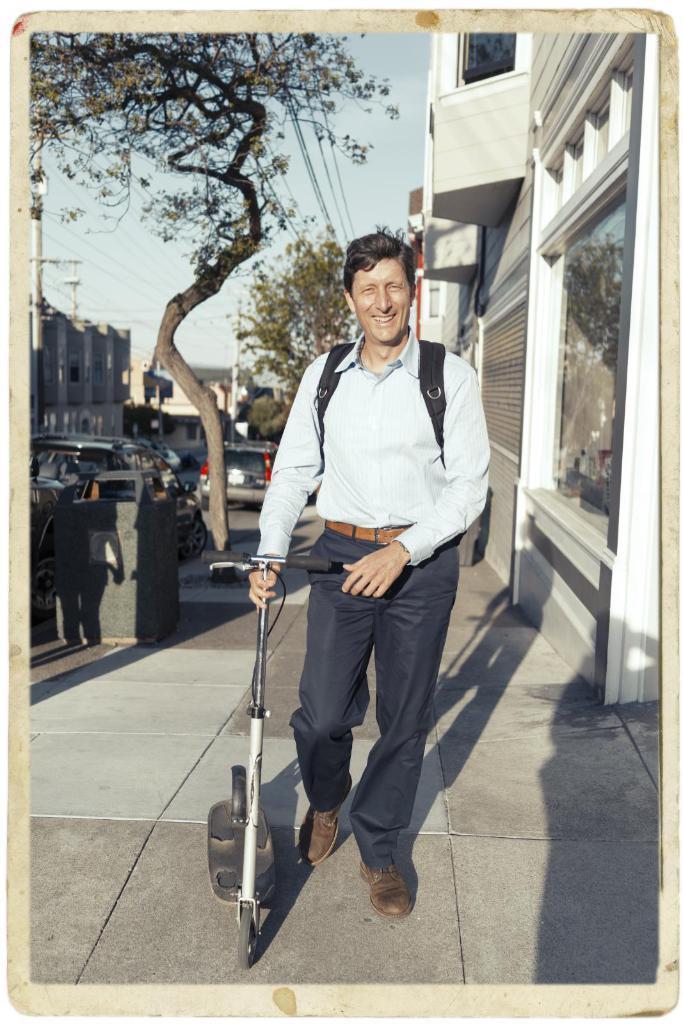Please provide a concise description of this image. There is a man holding a scooter with his hand and he is smiling. There are cars on the road. Here we can see trees, poles, bin, and buildings. In the background there is sky. 